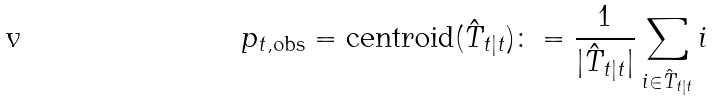Convert formula to latex. <formula><loc_0><loc_0><loc_500><loc_500>p _ { t , \text {obs} } = \text {centroid} ( \hat { T } _ { t | t } ) \colon = \frac { 1 } { | \hat { T } _ { t | t } | } \sum _ { i \in \hat { T } _ { t | t } } i</formula> 